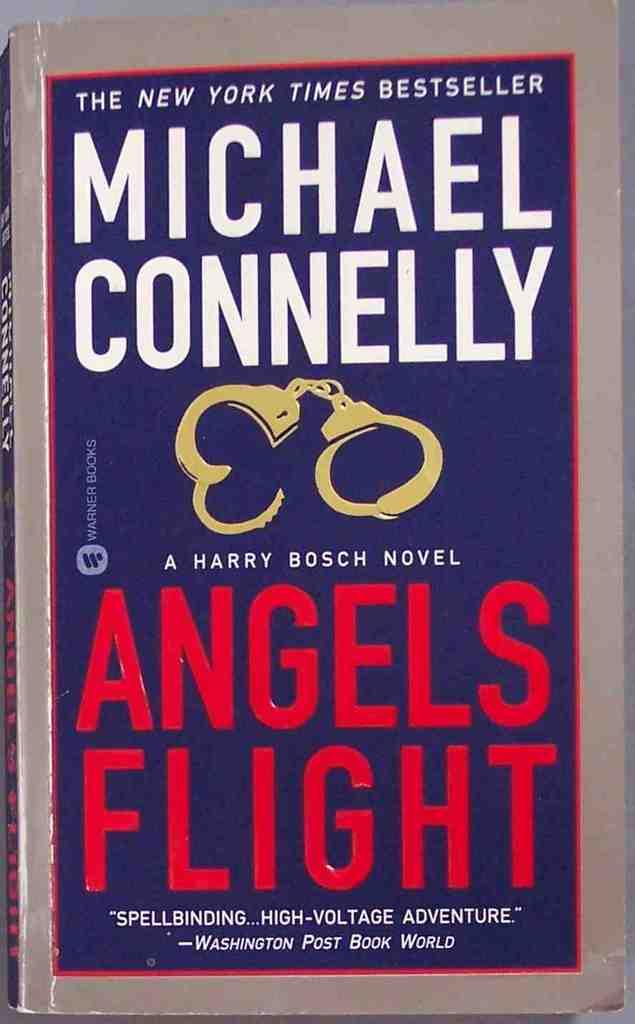What is present in the image related to reading material? There is a book in the image. What type of content does the book contain? The book contains text. Is there any illustration or image present in the book? Yes, there is a picture of handcuffs on the book. What type of sound can be heard coming from the book in the image? There is no sound coming from the book in the image, as it is a static object. What type of songs can be heard being sung by the book in the image? There is no indication that the book is capable of singing songs in the image. 